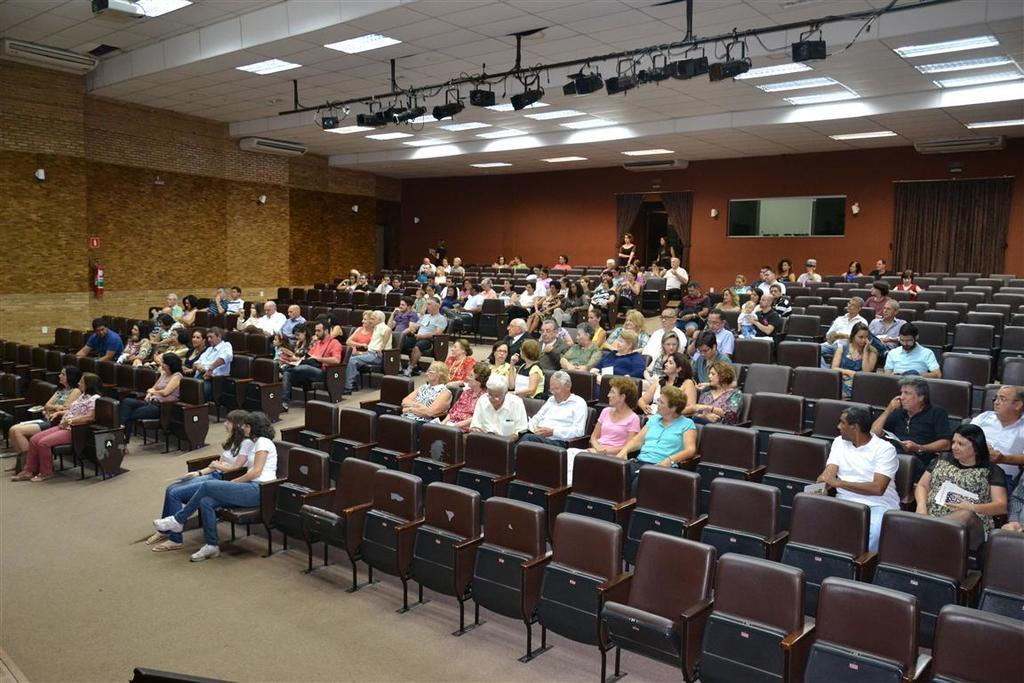Can you describe this image briefly? In the image I can see a hall in which there are some people who are sitting on the chairs and also I can see some lights to the roof. 